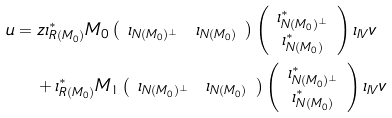<formula> <loc_0><loc_0><loc_500><loc_500>u & = z \iota _ { R ( M _ { 0 } ) } ^ { \ast } M _ { 0 } \left ( \begin{array} { c c } \iota _ { N ( M _ { 0 } ) ^ { \bot } } & \iota _ { N ( M _ { 0 } ) } \end{array} \right ) \left ( \begin{array} { c } \iota _ { N ( M _ { 0 } ) ^ { \bot } } ^ { * } \\ \iota _ { N ( M _ { 0 } ) } ^ { * } \end{array} \right ) \iota _ { I V } v \\ & \quad + \iota _ { R ( M _ { 0 } ) } ^ { \ast } M _ { 1 } \left ( \begin{array} { c c } \iota _ { N ( M _ { 0 } ) ^ { \bot } } & \iota _ { N ( M _ { 0 } ) } \end{array} \right ) \left ( \begin{array} { c } \iota _ { N ( M _ { 0 } ) ^ { \bot } } ^ { * } \\ \iota _ { N ( M _ { 0 } ) } ^ { * } \end{array} \right ) \iota _ { I V } v</formula> 